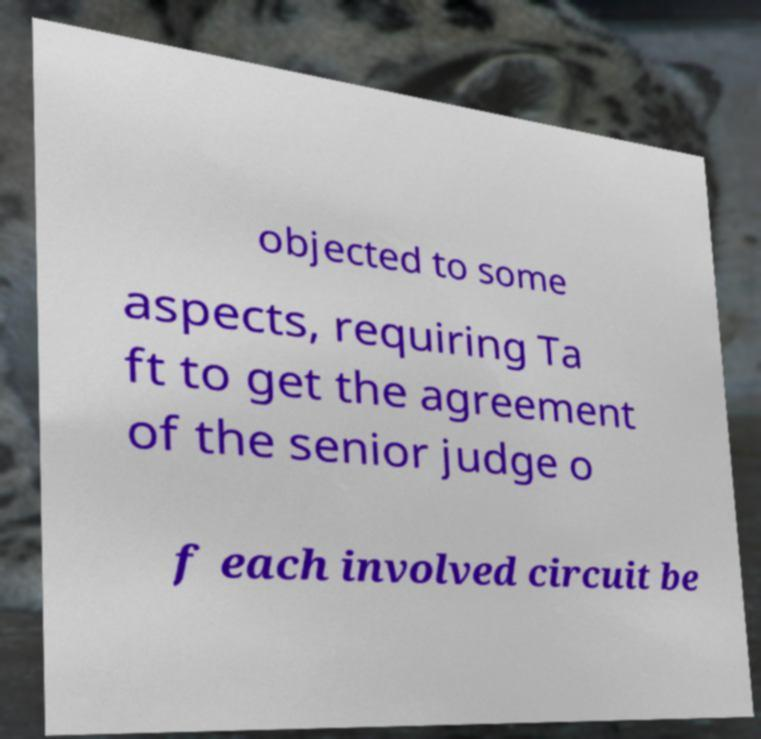For documentation purposes, I need the text within this image transcribed. Could you provide that? objected to some aspects, requiring Ta ft to get the agreement of the senior judge o f each involved circuit be 